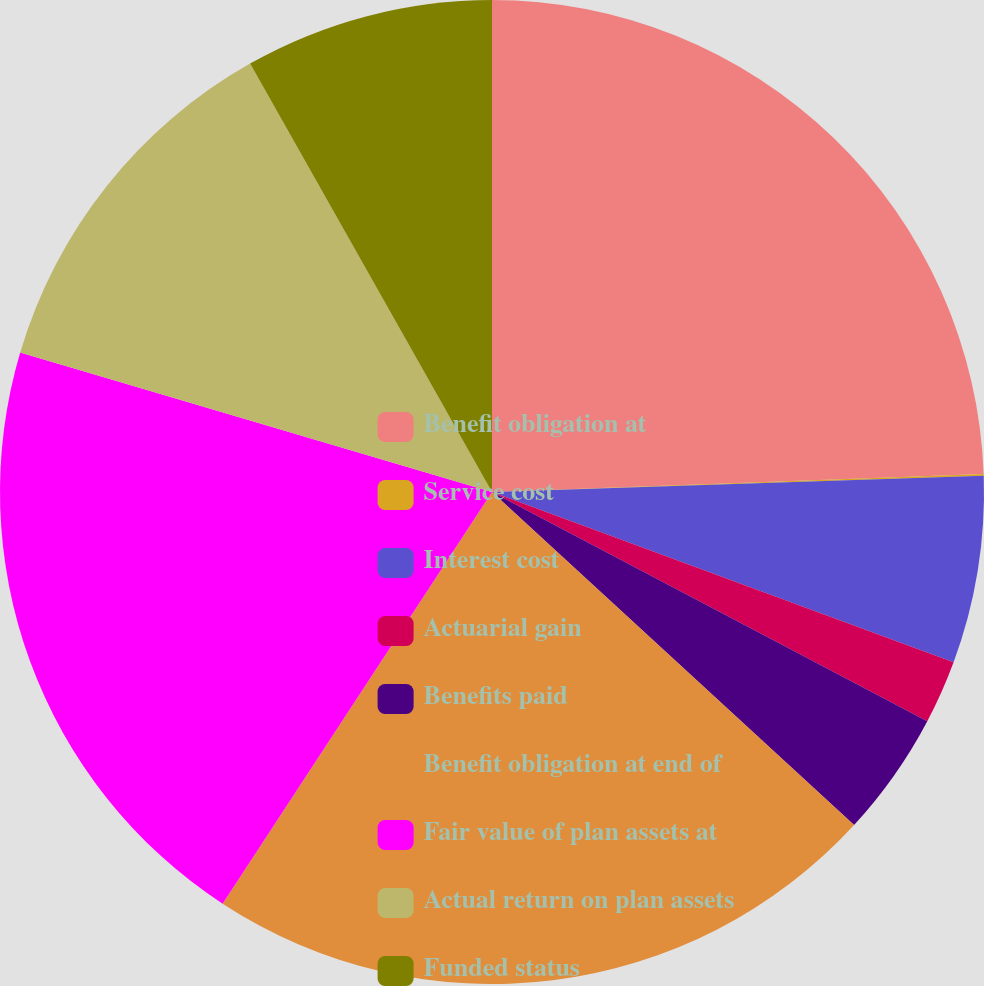<chart> <loc_0><loc_0><loc_500><loc_500><pie_chart><fcel>Benefit obligation at<fcel>Service cost<fcel>Interest cost<fcel>Actuarial gain<fcel>Benefits paid<fcel>Benefit obligation at end of<fcel>Fair value of plan assets at<fcel>Actual return on plan assets<fcel>Funded status<nl><fcel>24.41%<fcel>0.06%<fcel>6.15%<fcel>2.09%<fcel>4.12%<fcel>22.38%<fcel>20.35%<fcel>12.24%<fcel>8.18%<nl></chart> 